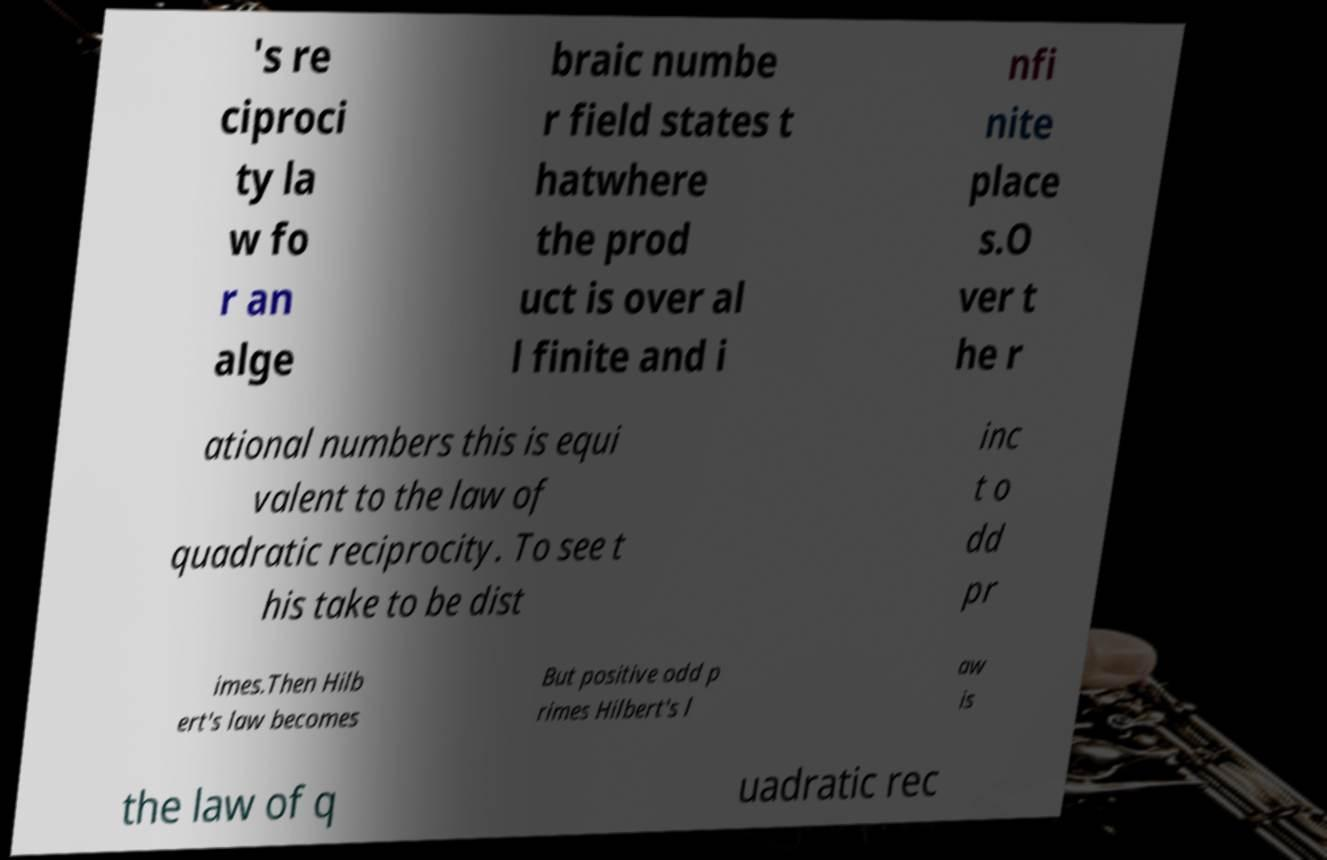I need the written content from this picture converted into text. Can you do that? 's re ciproci ty la w fo r an alge braic numbe r field states t hatwhere the prod uct is over al l finite and i nfi nite place s.O ver t he r ational numbers this is equi valent to the law of quadratic reciprocity. To see t his take to be dist inc t o dd pr imes.Then Hilb ert's law becomes But positive odd p rimes Hilbert's l aw is the law of q uadratic rec 